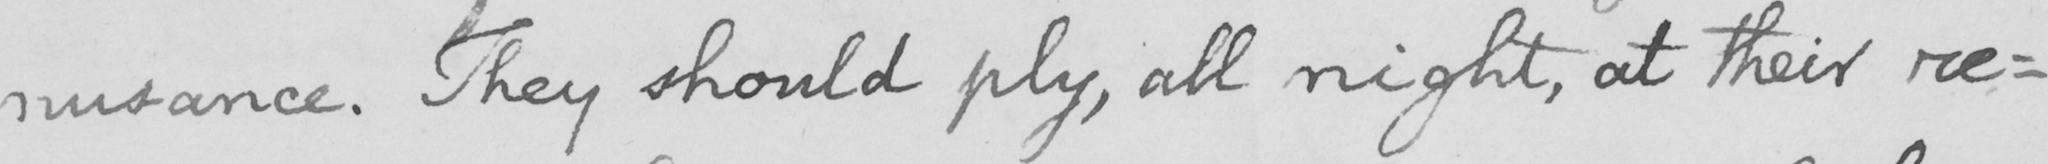Please transcribe the handwritten text in this image. nusance . They should ply , all night , at their re : 